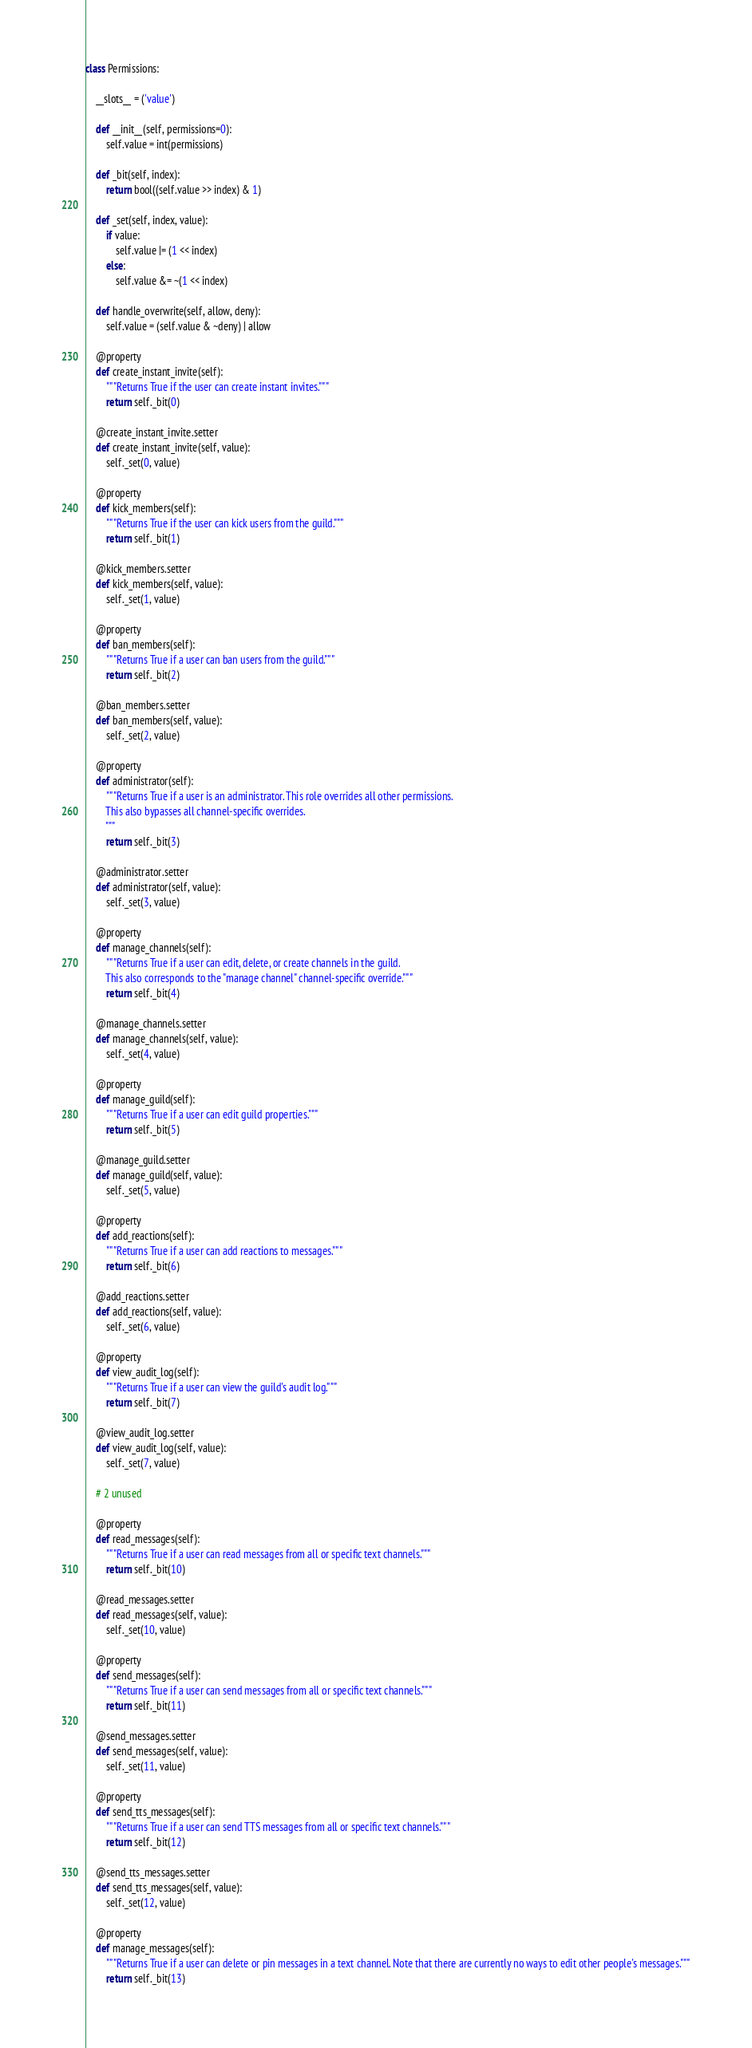Convert code to text. <code><loc_0><loc_0><loc_500><loc_500><_Python_>class Permissions:

    __slots__ = ('value')
    
    def __init__(self, permissions=0):
        self.value = int(permissions)

    def _bit(self, index):
        return bool((self.value >> index) & 1)

    def _set(self, index, value):
        if value:
            self.value |= (1 << index)
        else:
            self.value &= ~(1 << index)

    def handle_overwrite(self, allow, deny):
        self.value = (self.value & ~deny) | allow

    @property
    def create_instant_invite(self):
        """Returns True if the user can create instant invites."""
        return self._bit(0)

    @create_instant_invite.setter
    def create_instant_invite(self, value):
        self._set(0, value)

    @property
    def kick_members(self):
        """Returns True if the user can kick users from the guild."""
        return self._bit(1)

    @kick_members.setter
    def kick_members(self, value):
        self._set(1, value)

    @property
    def ban_members(self):
        """Returns True if a user can ban users from the guild."""
        return self._bit(2)

    @ban_members.setter
    def ban_members(self, value):
        self._set(2, value)

    @property
    def administrator(self):
        """Returns True if a user is an administrator. This role overrides all other permissions.
        This also bypasses all channel-specific overrides.
        """
        return self._bit(3)

    @administrator.setter
    def administrator(self, value):
        self._set(3, value)

    @property
    def manage_channels(self):
        """Returns True if a user can edit, delete, or create channels in the guild.
        This also corresponds to the "manage channel" channel-specific override."""
        return self._bit(4)

    @manage_channels.setter
    def manage_channels(self, value):
        self._set(4, value)

    @property
    def manage_guild(self):
        """Returns True if a user can edit guild properties."""
        return self._bit(5)

    @manage_guild.setter
    def manage_guild(self, value):
        self._set(5, value)

    @property
    def add_reactions(self):
        """Returns True if a user can add reactions to messages."""
        return self._bit(6)

    @add_reactions.setter
    def add_reactions(self, value):
        self._set(6, value)

    @property
    def view_audit_log(self):
        """Returns True if a user can view the guild's audit log."""
        return self._bit(7)

    @view_audit_log.setter
    def view_audit_log(self, value):
        self._set(7, value)

    # 2 unused

    @property
    def read_messages(self):
        """Returns True if a user can read messages from all or specific text channels."""
        return self._bit(10)

    @read_messages.setter
    def read_messages(self, value):
        self._set(10, value)

    @property
    def send_messages(self):
        """Returns True if a user can send messages from all or specific text channels."""
        return self._bit(11)

    @send_messages.setter
    def send_messages(self, value):
        self._set(11, value)

    @property
    def send_tts_messages(self):
        """Returns True if a user can send TTS messages from all or specific text channels."""
        return self._bit(12)

    @send_tts_messages.setter
    def send_tts_messages(self, value):
        self._set(12, value)

    @property
    def manage_messages(self):
        """Returns True if a user can delete or pin messages in a text channel. Note that there are currently no ways to edit other people's messages."""
        return self._bit(13)
</code> 